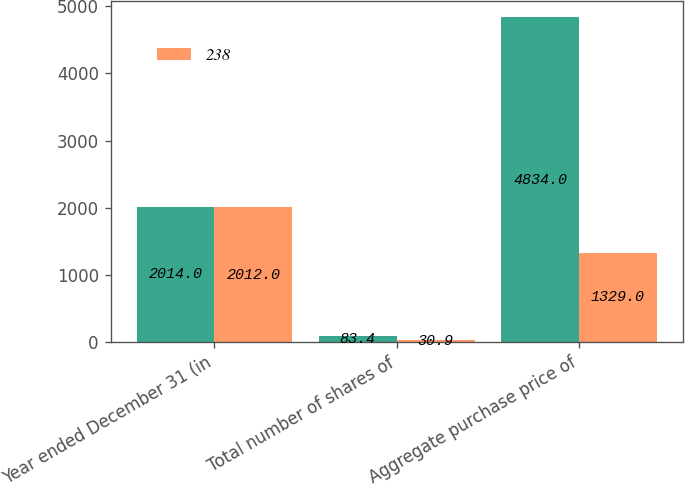Convert chart. <chart><loc_0><loc_0><loc_500><loc_500><stacked_bar_chart><ecel><fcel>Year ended December 31 (in<fcel>Total number of shares of<fcel>Aggregate purchase price of<nl><fcel>nan<fcel>2014<fcel>83.4<fcel>4834<nl><fcel>238<fcel>2012<fcel>30.9<fcel>1329<nl></chart> 